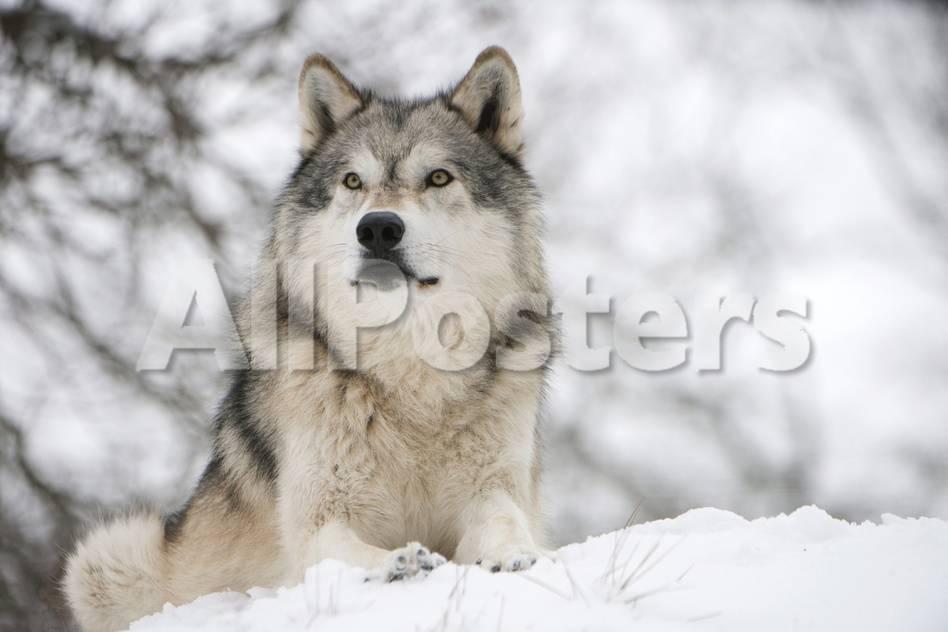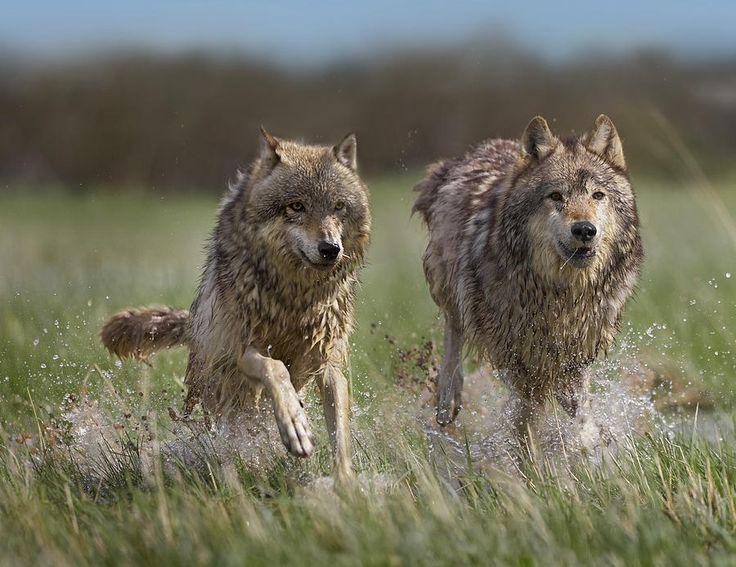The first image is the image on the left, the second image is the image on the right. Analyze the images presented: Is the assertion "In 1 of the images, 1 wolf is seated in snow." valid? Answer yes or no. Yes. The first image is the image on the left, the second image is the image on the right. Evaluate the accuracy of this statement regarding the images: "An image shows one wolf resting on the snow with front paws extended forward.". Is it true? Answer yes or no. Yes. 